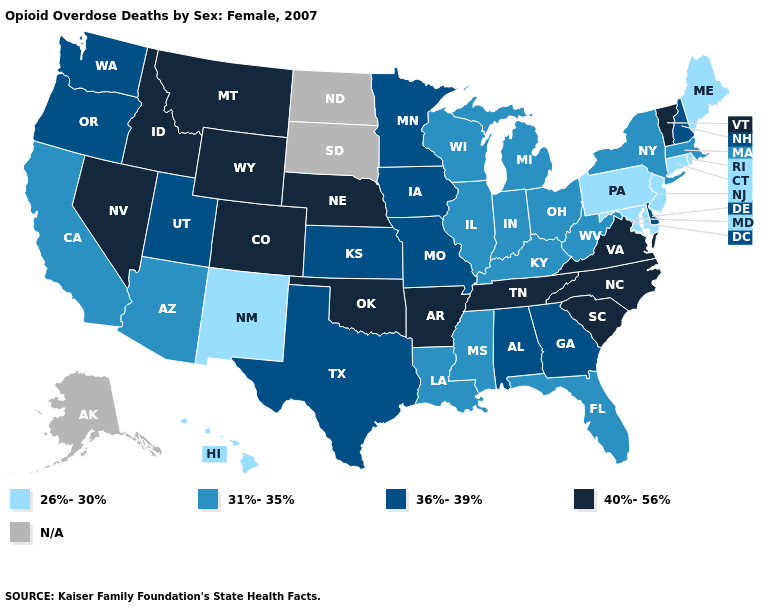Among the states that border South Dakota , which have the lowest value?
Concise answer only. Iowa, Minnesota. Name the states that have a value in the range N/A?
Write a very short answer. Alaska, North Dakota, South Dakota. Name the states that have a value in the range N/A?
Give a very brief answer. Alaska, North Dakota, South Dakota. What is the highest value in the USA?
Concise answer only. 40%-56%. Name the states that have a value in the range 36%-39%?
Be succinct. Alabama, Delaware, Georgia, Iowa, Kansas, Minnesota, Missouri, New Hampshire, Oregon, Texas, Utah, Washington. Does California have the highest value in the USA?
Concise answer only. No. Does Kentucky have the lowest value in the USA?
Concise answer only. No. What is the lowest value in the USA?
Answer briefly. 26%-30%. What is the highest value in the USA?
Keep it brief. 40%-56%. What is the value of Connecticut?
Concise answer only. 26%-30%. What is the value of West Virginia?
Answer briefly. 31%-35%. What is the value of Delaware?
Keep it brief. 36%-39%. Does Nebraska have the highest value in the MidWest?
Concise answer only. Yes. 